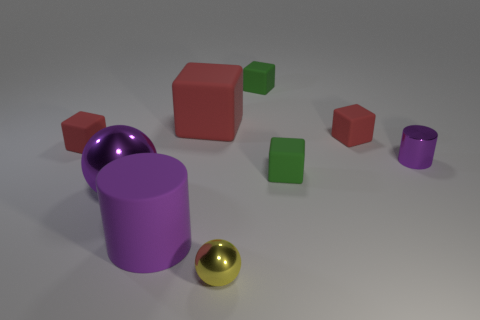Subtract all brown cylinders. How many red cubes are left? 3 Subtract all green blocks. How many blocks are left? 3 Subtract 2 cubes. How many cubes are left? 3 Subtract all big red blocks. How many blocks are left? 4 Subtract all cyan cubes. Subtract all gray spheres. How many cubes are left? 5 Subtract all spheres. How many objects are left? 7 Add 6 small red objects. How many small red objects are left? 8 Add 7 green blocks. How many green blocks exist? 9 Subtract 1 purple balls. How many objects are left? 8 Subtract all red rubber blocks. Subtract all blocks. How many objects are left? 1 